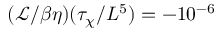Convert formula to latex. <formula><loc_0><loc_0><loc_500><loc_500>( \mathcal { L } / \beta \eta ) ( \tau _ { \chi } / L ^ { 5 } ) = - 1 0 ^ { - 6 }</formula> 